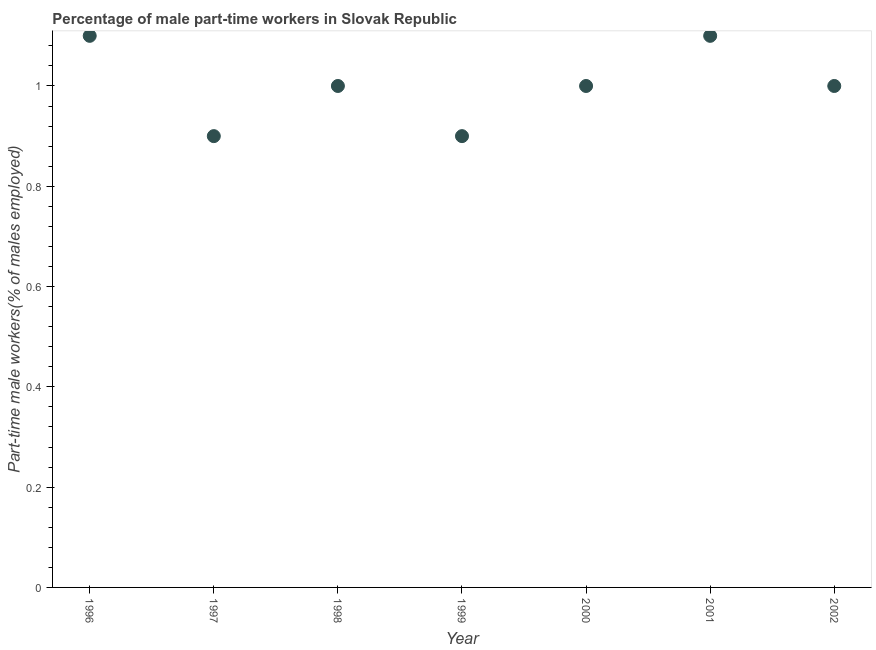What is the percentage of part-time male workers in 1996?
Offer a very short reply. 1.1. Across all years, what is the maximum percentage of part-time male workers?
Make the answer very short. 1.1. Across all years, what is the minimum percentage of part-time male workers?
Offer a terse response. 0.9. In which year was the percentage of part-time male workers maximum?
Your answer should be very brief. 1996. In which year was the percentage of part-time male workers minimum?
Provide a short and direct response. 1997. What is the sum of the percentage of part-time male workers?
Provide a short and direct response. 7. What is the difference between the percentage of part-time male workers in 1996 and 1998?
Provide a succinct answer. 0.1. What is the average percentage of part-time male workers per year?
Keep it short and to the point. 1. Do a majority of the years between 2001 and 2002 (inclusive) have percentage of part-time male workers greater than 0.6000000000000001 %?
Provide a succinct answer. Yes. What is the ratio of the percentage of part-time male workers in 2000 to that in 2001?
Offer a very short reply. 0.91. What is the difference between the highest and the second highest percentage of part-time male workers?
Ensure brevity in your answer.  0. What is the difference between the highest and the lowest percentage of part-time male workers?
Make the answer very short. 0.2. Does the percentage of part-time male workers monotonically increase over the years?
Your answer should be very brief. No. How many dotlines are there?
Your response must be concise. 1. Does the graph contain any zero values?
Give a very brief answer. No. Does the graph contain grids?
Your answer should be compact. No. What is the title of the graph?
Ensure brevity in your answer.  Percentage of male part-time workers in Slovak Republic. What is the label or title of the Y-axis?
Your response must be concise. Part-time male workers(% of males employed). What is the Part-time male workers(% of males employed) in 1996?
Keep it short and to the point. 1.1. What is the Part-time male workers(% of males employed) in 1997?
Offer a very short reply. 0.9. What is the Part-time male workers(% of males employed) in 1998?
Make the answer very short. 1. What is the Part-time male workers(% of males employed) in 1999?
Provide a short and direct response. 0.9. What is the Part-time male workers(% of males employed) in 2000?
Provide a short and direct response. 1. What is the Part-time male workers(% of males employed) in 2001?
Provide a succinct answer. 1.1. What is the difference between the Part-time male workers(% of males employed) in 1996 and 1998?
Your answer should be very brief. 0.1. What is the difference between the Part-time male workers(% of males employed) in 1996 and 2000?
Ensure brevity in your answer.  0.1. What is the difference between the Part-time male workers(% of males employed) in 1996 and 2001?
Offer a terse response. 0. What is the difference between the Part-time male workers(% of males employed) in 1997 and 1998?
Provide a succinct answer. -0.1. What is the difference between the Part-time male workers(% of males employed) in 1997 and 2001?
Offer a terse response. -0.2. What is the difference between the Part-time male workers(% of males employed) in 1998 and 2000?
Keep it short and to the point. 0. What is the difference between the Part-time male workers(% of males employed) in 2000 and 2001?
Provide a short and direct response. -0.1. What is the difference between the Part-time male workers(% of males employed) in 2000 and 2002?
Offer a terse response. 0. What is the ratio of the Part-time male workers(% of males employed) in 1996 to that in 1997?
Offer a very short reply. 1.22. What is the ratio of the Part-time male workers(% of males employed) in 1996 to that in 1999?
Your response must be concise. 1.22. What is the ratio of the Part-time male workers(% of males employed) in 1996 to that in 2000?
Ensure brevity in your answer.  1.1. What is the ratio of the Part-time male workers(% of males employed) in 1996 to that in 2002?
Your answer should be very brief. 1.1. What is the ratio of the Part-time male workers(% of males employed) in 1997 to that in 1998?
Provide a succinct answer. 0.9. What is the ratio of the Part-time male workers(% of males employed) in 1997 to that in 1999?
Provide a succinct answer. 1. What is the ratio of the Part-time male workers(% of males employed) in 1997 to that in 2001?
Give a very brief answer. 0.82. What is the ratio of the Part-time male workers(% of males employed) in 1997 to that in 2002?
Your answer should be compact. 0.9. What is the ratio of the Part-time male workers(% of males employed) in 1998 to that in 1999?
Your answer should be compact. 1.11. What is the ratio of the Part-time male workers(% of males employed) in 1998 to that in 2000?
Provide a succinct answer. 1. What is the ratio of the Part-time male workers(% of males employed) in 1998 to that in 2001?
Give a very brief answer. 0.91. What is the ratio of the Part-time male workers(% of males employed) in 1998 to that in 2002?
Your response must be concise. 1. What is the ratio of the Part-time male workers(% of males employed) in 1999 to that in 2001?
Make the answer very short. 0.82. What is the ratio of the Part-time male workers(% of males employed) in 2000 to that in 2001?
Offer a very short reply. 0.91. What is the ratio of the Part-time male workers(% of males employed) in 2001 to that in 2002?
Your answer should be very brief. 1.1. 